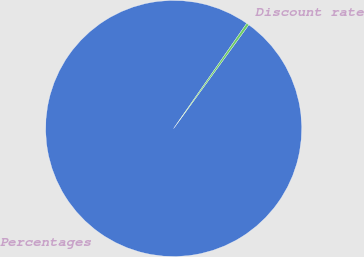Convert chart to OTSL. <chart><loc_0><loc_0><loc_500><loc_500><pie_chart><fcel>Percentages<fcel>Discount rate<nl><fcel>99.68%<fcel>0.32%<nl></chart> 